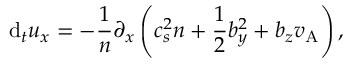Convert formula to latex. <formula><loc_0><loc_0><loc_500><loc_500>d _ { t } u _ { x } = - \frac { 1 } { n } \partial _ { x } \left ( c _ { s } ^ { 2 } n + \frac { 1 } { 2 } b _ { y } ^ { 2 } + b _ { z } v _ { A } \right ) ,</formula> 